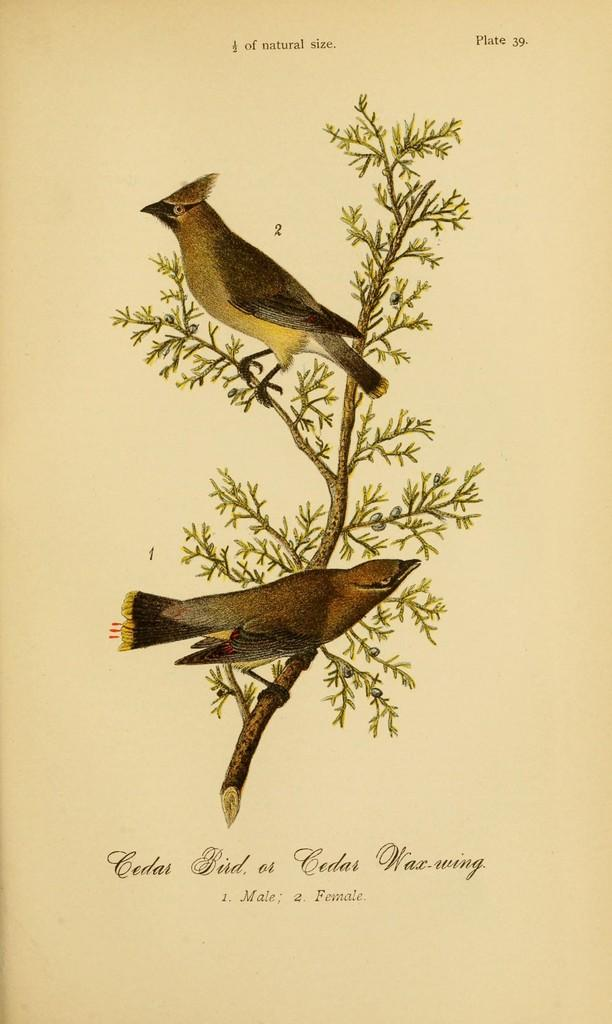What is depicted on the paper in the image? There is art on a paper in the image. How many apples are stitched onto the art in the image? There is no mention of apples or stitching in the image, as it only features art on a paper. 